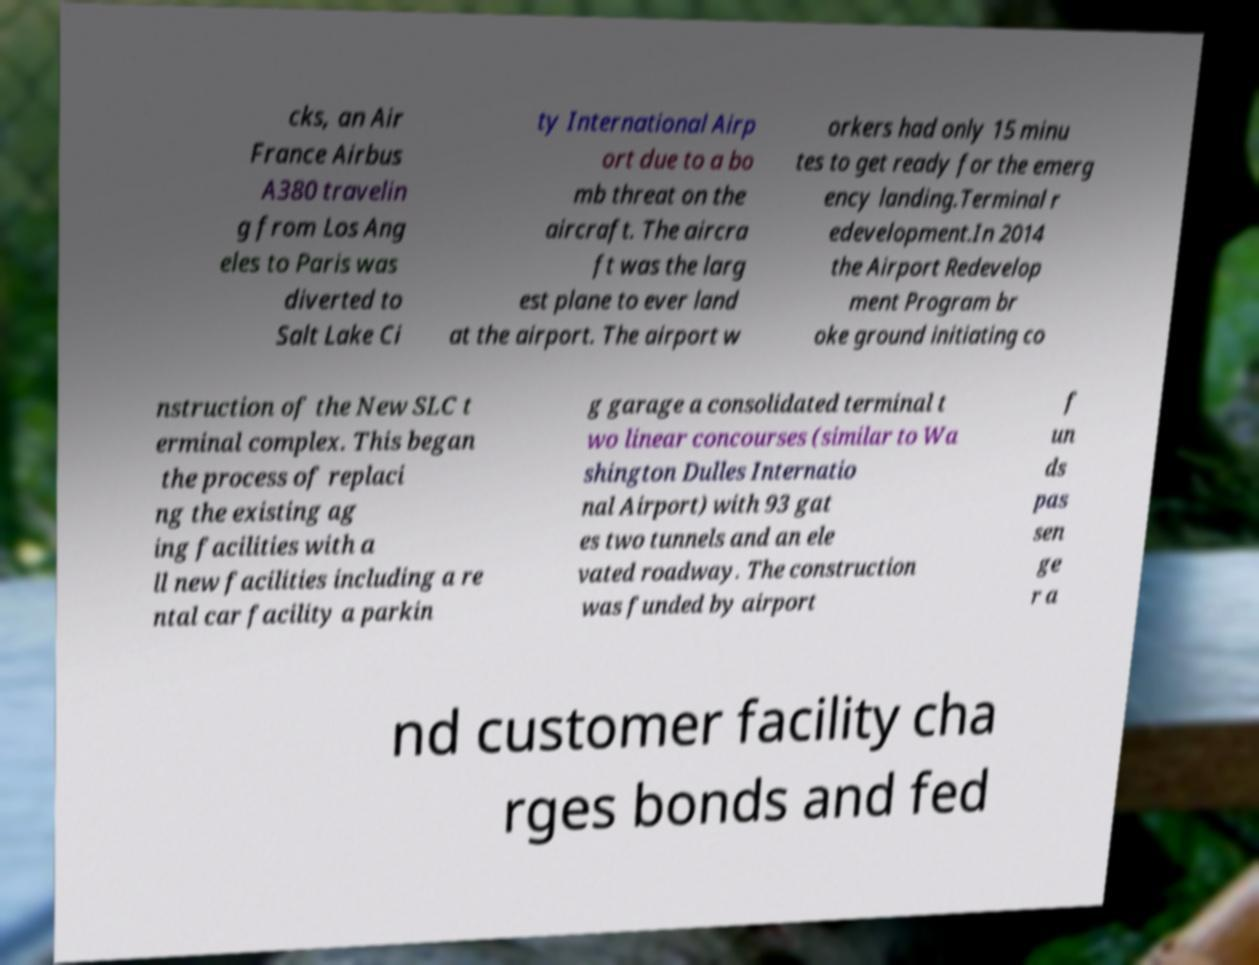For documentation purposes, I need the text within this image transcribed. Could you provide that? cks, an Air France Airbus A380 travelin g from Los Ang eles to Paris was diverted to Salt Lake Ci ty International Airp ort due to a bo mb threat on the aircraft. The aircra ft was the larg est plane to ever land at the airport. The airport w orkers had only 15 minu tes to get ready for the emerg ency landing.Terminal r edevelopment.In 2014 the Airport Redevelop ment Program br oke ground initiating co nstruction of the New SLC t erminal complex. This began the process of replaci ng the existing ag ing facilities with a ll new facilities including a re ntal car facility a parkin g garage a consolidated terminal t wo linear concourses (similar to Wa shington Dulles Internatio nal Airport) with 93 gat es two tunnels and an ele vated roadway. The construction was funded by airport f un ds pas sen ge r a nd customer facility cha rges bonds and fed 